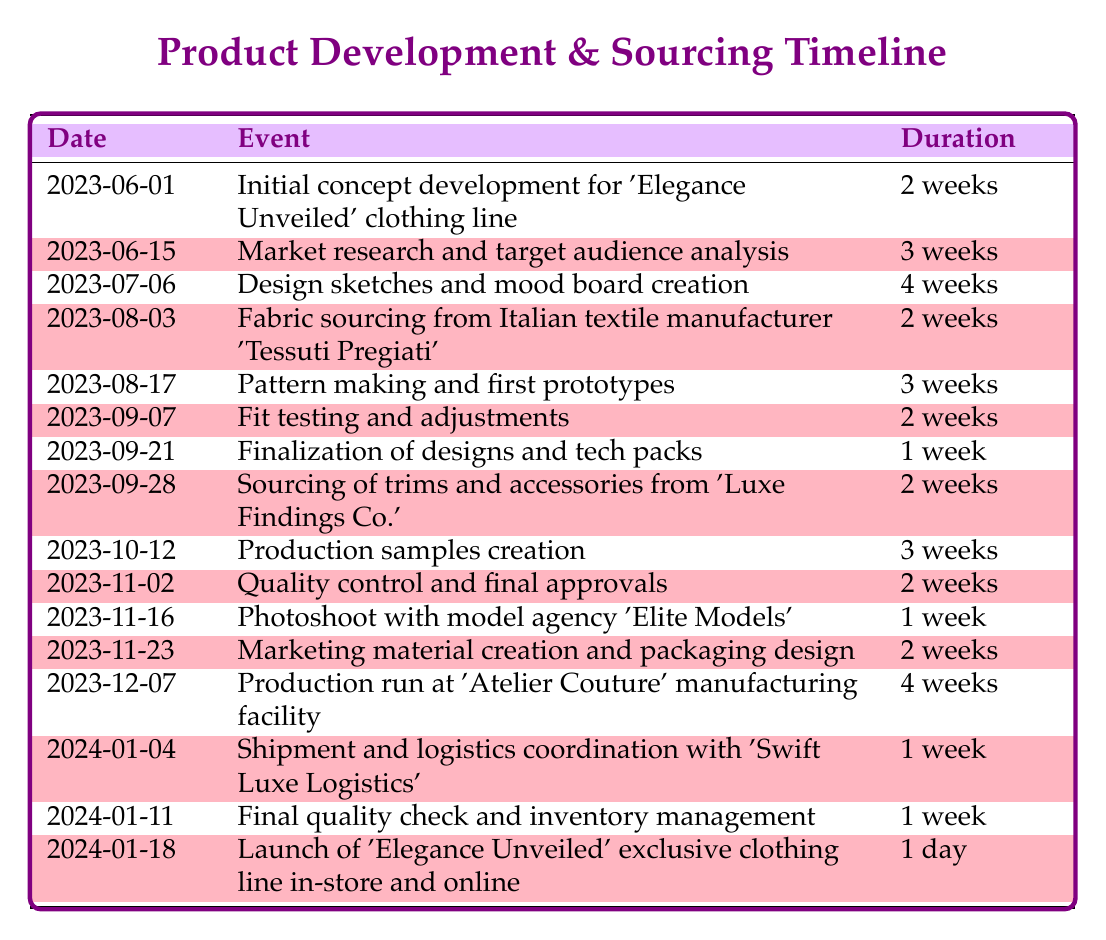What is the event that occurs on July 6, 2023? Referring to the table, the event listed for July 6, 2023, is "Design sketches and mood board creation."
Answer: Design sketches and mood board creation How long does the pattern making and first prototypes phase last? By looking at the duration column, the duration for "Pattern making and first prototypes," which begins on August 17, 2023, is 3 weeks.
Answer: 3 weeks Is there a photoshoot scheduled before the quality control and final approvals? The timeline shows that the photoshoot is scheduled for November 16, 2023, and the quality control and final approvals occur on November 2, 2023. Since November 2 comes before November 16, the statement is true.
Answer: Yes What is the total duration for the entire product development process? The total duration can be calculated by summing the durations from each phase. The phases are as follows: 2+3+4+2+3+2+1+2+3+2+1+2+4+1+1+1 = 30 weeks and 1 day.
Answer: 30 weeks and 1 day What is the date for the launch of 'Elegance Unveiled'? The launch date for 'Elegance Unveiled' is provided in the table as January 18, 2024.
Answer: January 18, 2024 How many weeks are there between starting fabric sourcing and the final quality check? Fabric sourcing starts on August 3, 2023, and the final quality check occurs on January 11, 2024. Counting the weeks involves calculating the total duration between these two dates: August 3 to January 11 spans roughly 22 weeks, including the end dates.
Answer: 22 weeks Was there any time spent on market research before starting design sketches? Market research occurs from June 15, 2023, to July 6, 2023, which is before the design sketches start on July 6, 2023. Therefore, the statement is true.
Answer: Yes What activity follows the creation of marketing materials? According to the table, the event that follows "Marketing material creation and packaging design," which ends on December 21, 2023, is the production run at 'Atelier Couture' on December 7, 2023.
Answer: Production run at 'Atelier Couture' 